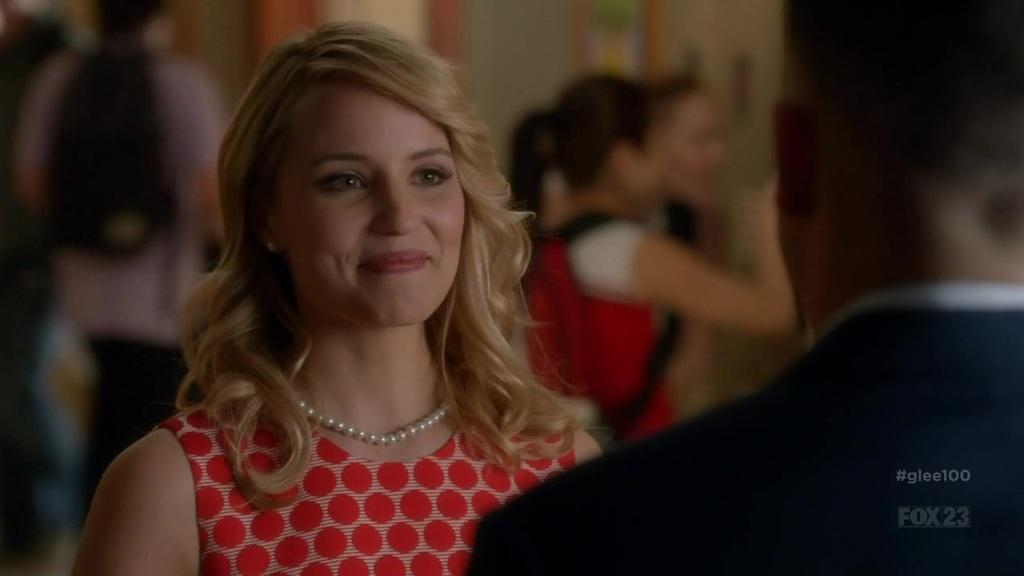What is happening with the persons in the image? The persons in the image are standing and smiling. Can you describe the background of the image? The background of the image is blurred. What type of squirrel can be seen wearing apparel in the image? There is no squirrel present in the image, let alone one wearing apparel. 